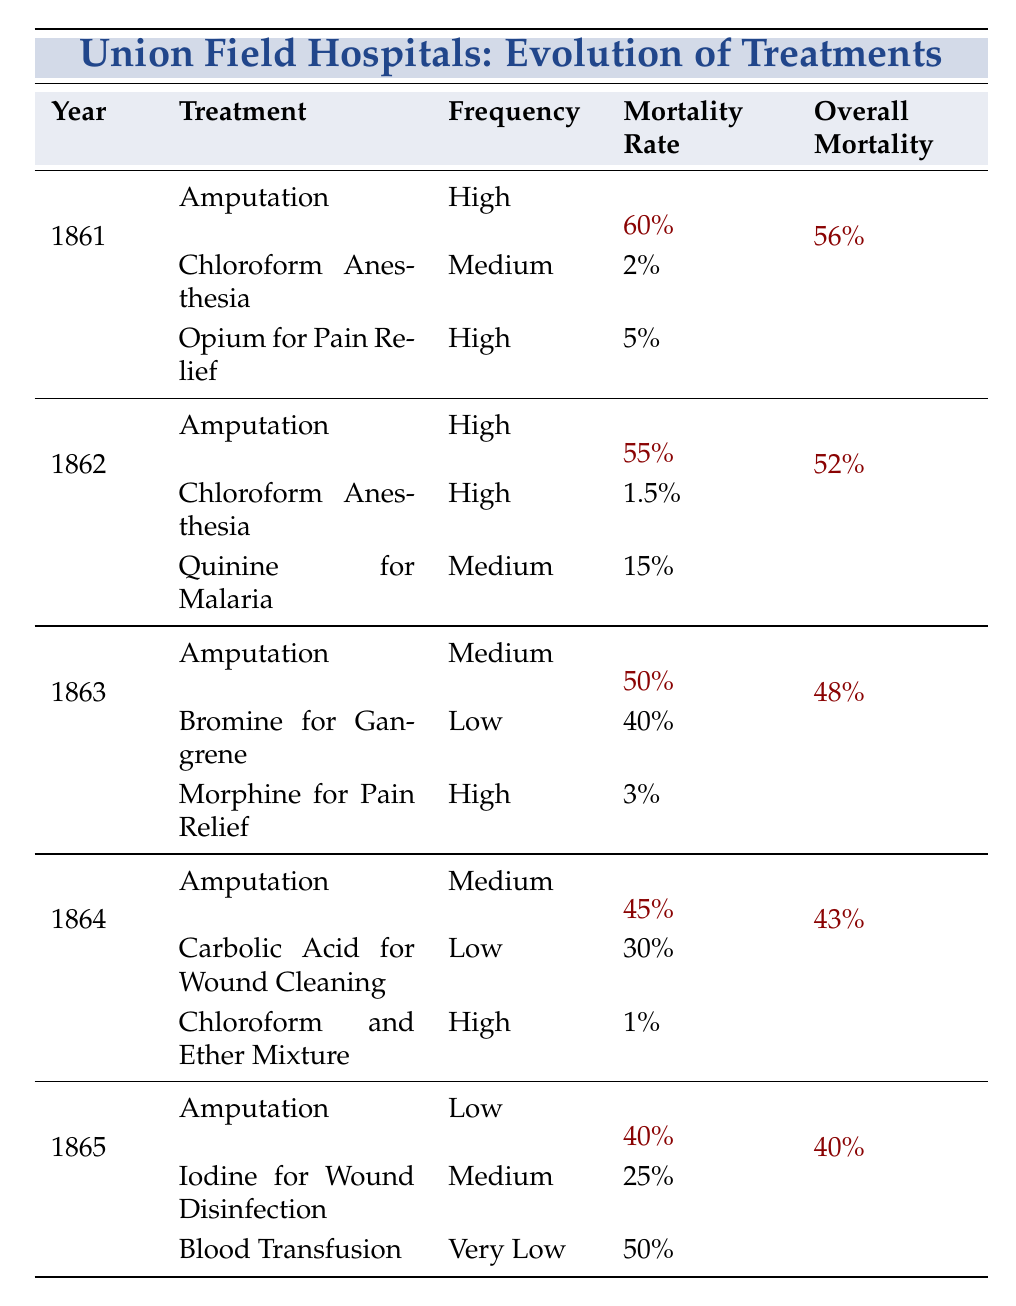What was the overall mortality rate in 1863? The table shows that the overall mortality rate for 1863 is listed directly as 48%.
Answer: 48% Which treatment had the highest mortality rate in 1861? In 1861, the treatments listed with their mortality rates are: Amputation (60%), Chloroform Anesthesia (2%), and Opium for Pain Relief (5%). The highest is Amputation with 60%.
Answer: Amputation Did the use of Chloroform Anesthesia increase or decrease in mortality rate from 1861 to 1864? In 1861, Chloroform Anesthesia had a mortality rate of 2%, while in 1864, it was reduced to 1%. This indicates a decrease in mortality rate.
Answer: Decrease What is the difference in overall mortality rates between 1861 and 1865? The overall mortality rate in 1861 is 56% and in 1865 is 40%. The difference is calculated as 56% - 40% = 16%.
Answer: 16% Which year had the lowest overall mortality rate and what was it? By examining the table, the overall mortality rates for each year are: 1861 (56%), 1862 (52%), 1863 (48%), 1864 (43%), and 1865 (40%). The lowest is in 1865 with 40%.
Answer: 1865, 40% Was there any treatment used in 1865 that had a mortality rate of over 50%? In 1865, the treatments listed have mortality rates: Amputation (40%), Iodine for Wound Disinfection (25%), and Blood Transfusion (50%). None of these exceed 50%, so the answer is no.
Answer: No What was the average mortality rate of Amputation from 1861 to 1865? The mortality rates for Amputation are: 60% (1861), 55% (1862), 50% (1863), 45% (1864), and 40% (1865). Summing these up gives 60 + 55 + 50 + 45 + 40 = 250%, and dividing by 5 gives an average of 50%.
Answer: 50% Did the mortality rate for Opium for Pain Relief change over the years it was recorded? Opium for Pain Relief was recorded only in 1861 with a mortality rate of 5%. Since it's not present in subsequent years, we cannot determine a change; hence, the answer is no.
Answer: No In which year was the mortality rate for Quinine for Malaria the highest? The table shows Quinine for Malaria with a mortality rate of 15% in 1862. It is not listed in other years. Therefore, 1862 has the highest mortality rate for this treatment.
Answer: 1862, 15% Which treatment showed improvement in mortality rate from the year 1862 to 1864? Chloroform Anesthesia improved from 1.5% in 1862 to 1% in 1864, showing a decrease in mortality rate.
Answer: Chloroform Anesthesia What trend is observed in the frequency of Amputation from 1861 to 1865? The frequency starts as High in 1861, remains High in 1862, changes to Medium in 1863 and 1864, and finally to Low in 1865. The trend shows a decline in frequency.
Answer: Decline in frequency 